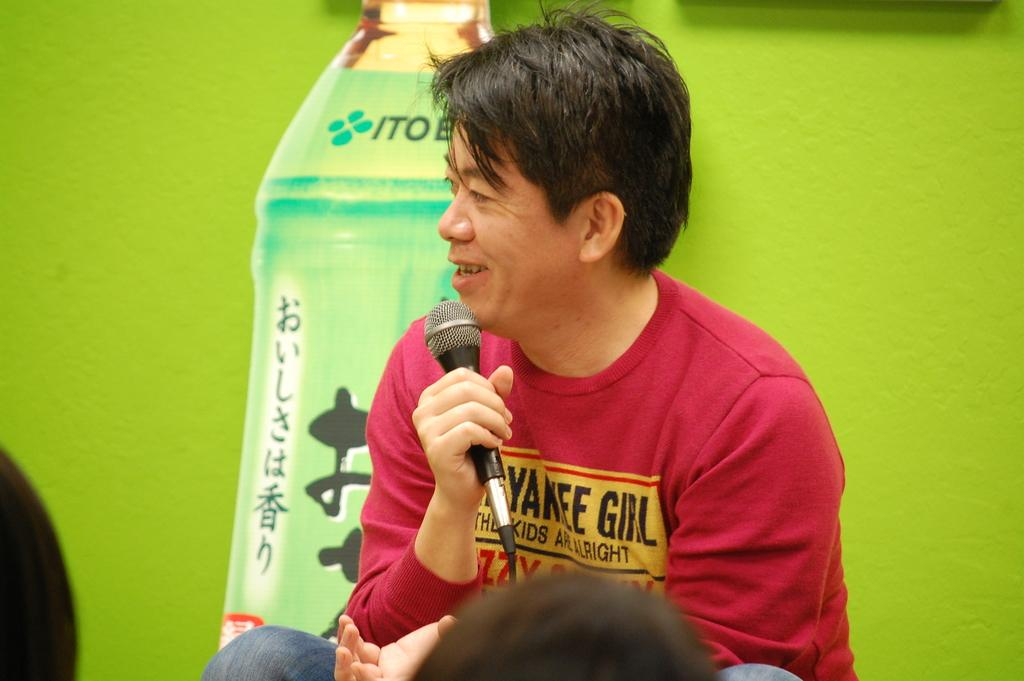Who is the main subject in the image? There is a man in the image. What is the man holding in the image? The man is holding a microphone. What is the man doing in the image? The man is talking. What color is the wall in the background of the image? There is a green color wall in the background of the image. What type of shoe is the man wearing in the image? The image does not show the man's shoes, so it is not possible to determine what type of shoe he is wearing. 